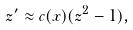<formula> <loc_0><loc_0><loc_500><loc_500>z ^ { \prime } \approx c ( x ) ( z ^ { 2 } - 1 ) ,</formula> 